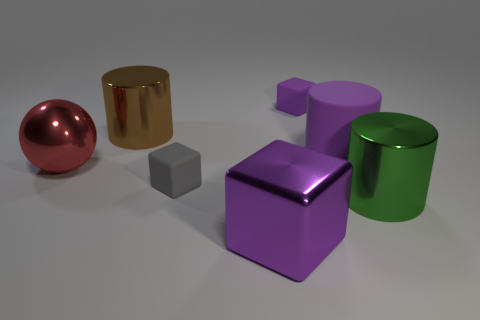Subtract all big metallic blocks. How many blocks are left? 2 Subtract all green spheres. How many purple blocks are left? 2 Subtract 1 cylinders. How many cylinders are left? 2 Add 2 balls. How many objects exist? 9 Subtract all brown cylinders. How many cylinders are left? 2 Subtract all cylinders. How many objects are left? 4 Subtract all brown cubes. Subtract all blue spheres. How many cubes are left? 3 Subtract 0 yellow cylinders. How many objects are left? 7 Subtract all blue rubber objects. Subtract all large purple shiny things. How many objects are left? 6 Add 1 tiny gray matte blocks. How many tiny gray matte blocks are left? 2 